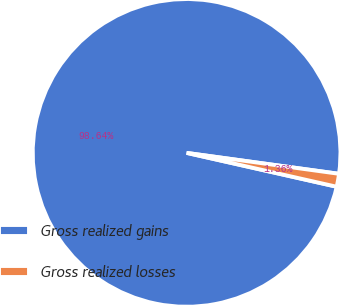<chart> <loc_0><loc_0><loc_500><loc_500><pie_chart><fcel>Gross realized gains<fcel>Gross realized losses<nl><fcel>98.64%<fcel>1.36%<nl></chart> 